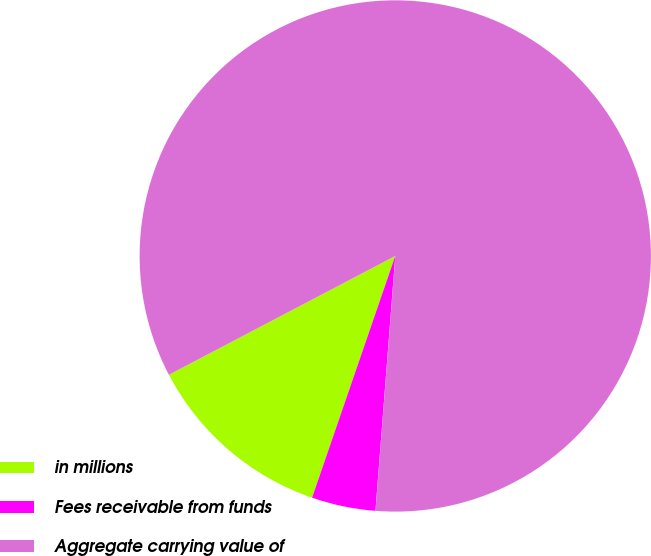Convert chart to OTSL. <chart><loc_0><loc_0><loc_500><loc_500><pie_chart><fcel>in millions<fcel>Fees receivable from funds<fcel>Aggregate carrying value of<nl><fcel>12.03%<fcel>4.04%<fcel>83.92%<nl></chart> 